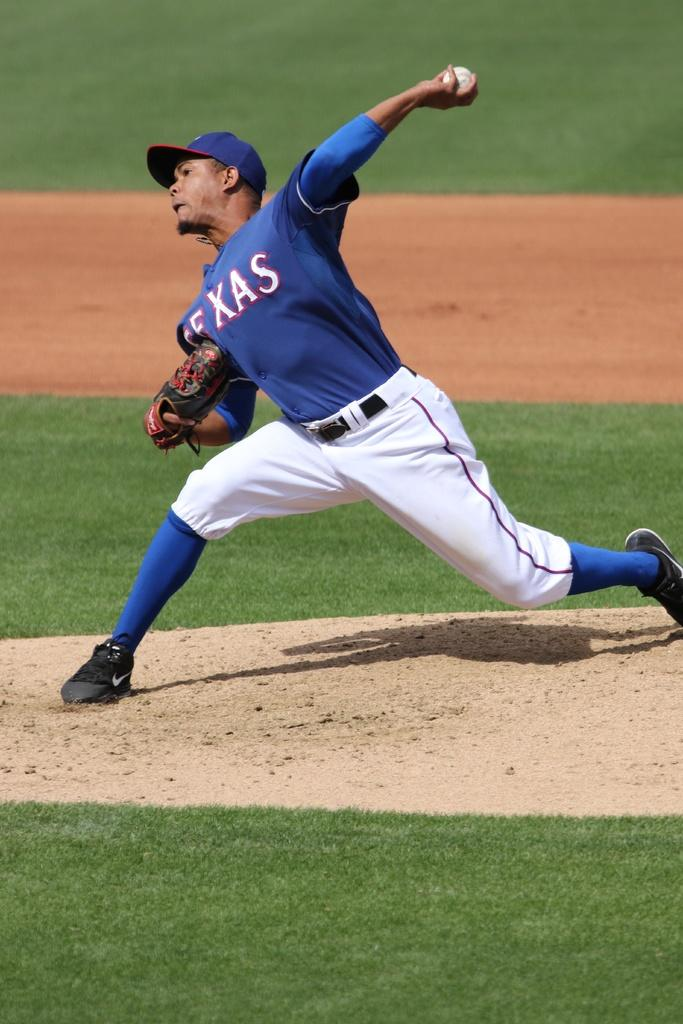<image>
Create a compact narrative representing the image presented. Texas is the team name shown on the pitcher's jersey. 